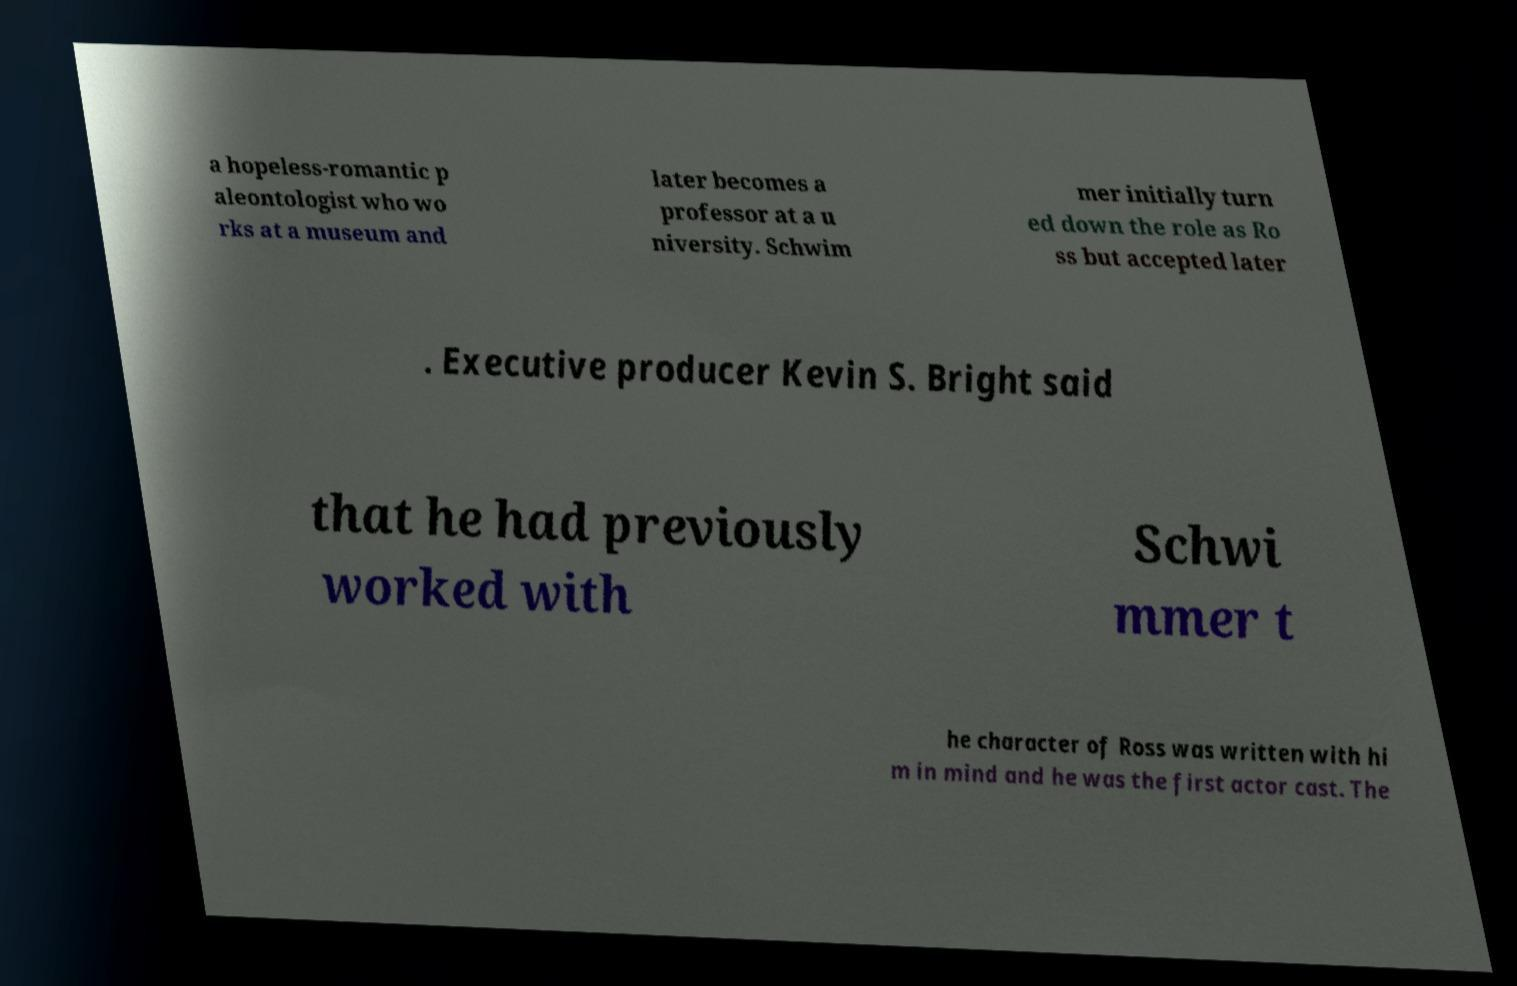What messages or text are displayed in this image? I need them in a readable, typed format. a hopeless-romantic p aleontologist who wo rks at a museum and later becomes a professor at a u niversity. Schwim mer initially turn ed down the role as Ro ss but accepted later . Executive producer Kevin S. Bright said that he had previously worked with Schwi mmer t he character of Ross was written with hi m in mind and he was the first actor cast. The 